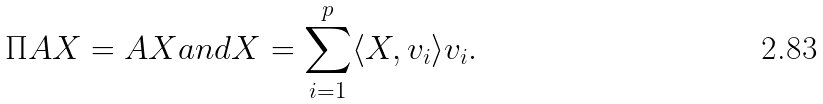Convert formula to latex. <formula><loc_0><loc_0><loc_500><loc_500>\Pi A X = A X a n d X = \sum _ { i = 1 } ^ { p } \langle X , v _ { i } \rangle v _ { i } .</formula> 